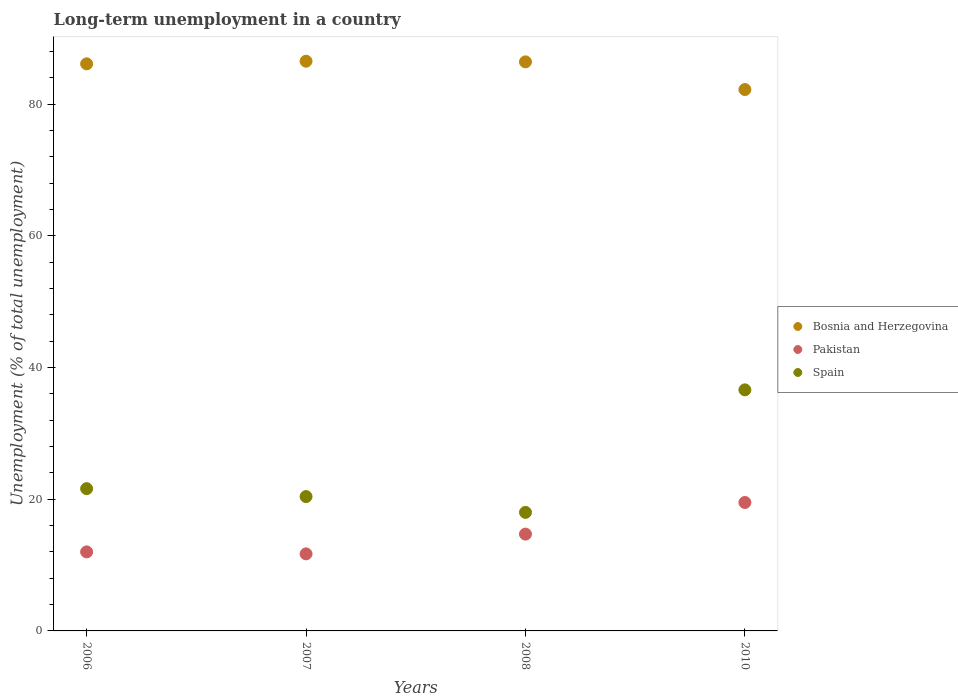Across all years, what is the minimum percentage of long-term unemployed population in Pakistan?
Provide a short and direct response. 11.7. In which year was the percentage of long-term unemployed population in Pakistan maximum?
Keep it short and to the point. 2010. What is the total percentage of long-term unemployed population in Spain in the graph?
Your response must be concise. 96.6. What is the difference between the percentage of long-term unemployed population in Bosnia and Herzegovina in 2006 and that in 2010?
Your answer should be compact. 3.9. What is the average percentage of long-term unemployed population in Pakistan per year?
Ensure brevity in your answer.  14.47. In the year 2006, what is the difference between the percentage of long-term unemployed population in Spain and percentage of long-term unemployed population in Pakistan?
Give a very brief answer. 9.6. In how many years, is the percentage of long-term unemployed population in Spain greater than 16 %?
Provide a succinct answer. 4. What is the ratio of the percentage of long-term unemployed population in Pakistan in 2007 to that in 2008?
Offer a terse response. 0.8. Is the difference between the percentage of long-term unemployed population in Spain in 2007 and 2010 greater than the difference between the percentage of long-term unemployed population in Pakistan in 2007 and 2010?
Offer a very short reply. No. What is the difference between the highest and the second highest percentage of long-term unemployed population in Spain?
Provide a short and direct response. 15. What is the difference between the highest and the lowest percentage of long-term unemployed population in Bosnia and Herzegovina?
Keep it short and to the point. 4.3. In how many years, is the percentage of long-term unemployed population in Spain greater than the average percentage of long-term unemployed population in Spain taken over all years?
Offer a very short reply. 1. Is the sum of the percentage of long-term unemployed population in Spain in 2006 and 2007 greater than the maximum percentage of long-term unemployed population in Pakistan across all years?
Give a very brief answer. Yes. Does the percentage of long-term unemployed population in Pakistan monotonically increase over the years?
Make the answer very short. No. Is the percentage of long-term unemployed population in Spain strictly greater than the percentage of long-term unemployed population in Pakistan over the years?
Keep it short and to the point. Yes. Is the percentage of long-term unemployed population in Pakistan strictly less than the percentage of long-term unemployed population in Spain over the years?
Keep it short and to the point. Yes. How many years are there in the graph?
Make the answer very short. 4. What is the difference between two consecutive major ticks on the Y-axis?
Provide a short and direct response. 20. Does the graph contain any zero values?
Keep it short and to the point. No. Does the graph contain grids?
Your response must be concise. No. Where does the legend appear in the graph?
Provide a short and direct response. Center right. What is the title of the graph?
Offer a terse response. Long-term unemployment in a country. Does "Colombia" appear as one of the legend labels in the graph?
Your answer should be very brief. No. What is the label or title of the X-axis?
Your response must be concise. Years. What is the label or title of the Y-axis?
Your answer should be very brief. Unemployment (% of total unemployment). What is the Unemployment (% of total unemployment) in Bosnia and Herzegovina in 2006?
Your answer should be compact. 86.1. What is the Unemployment (% of total unemployment) in Spain in 2006?
Offer a terse response. 21.6. What is the Unemployment (% of total unemployment) in Bosnia and Herzegovina in 2007?
Provide a succinct answer. 86.5. What is the Unemployment (% of total unemployment) in Pakistan in 2007?
Keep it short and to the point. 11.7. What is the Unemployment (% of total unemployment) in Spain in 2007?
Offer a terse response. 20.4. What is the Unemployment (% of total unemployment) of Bosnia and Herzegovina in 2008?
Offer a terse response. 86.4. What is the Unemployment (% of total unemployment) in Pakistan in 2008?
Your answer should be compact. 14.7. What is the Unemployment (% of total unemployment) in Bosnia and Herzegovina in 2010?
Make the answer very short. 82.2. What is the Unemployment (% of total unemployment) of Spain in 2010?
Provide a short and direct response. 36.6. Across all years, what is the maximum Unemployment (% of total unemployment) of Bosnia and Herzegovina?
Ensure brevity in your answer.  86.5. Across all years, what is the maximum Unemployment (% of total unemployment) of Pakistan?
Your answer should be compact. 19.5. Across all years, what is the maximum Unemployment (% of total unemployment) in Spain?
Offer a terse response. 36.6. Across all years, what is the minimum Unemployment (% of total unemployment) in Bosnia and Herzegovina?
Give a very brief answer. 82.2. Across all years, what is the minimum Unemployment (% of total unemployment) in Pakistan?
Your response must be concise. 11.7. Across all years, what is the minimum Unemployment (% of total unemployment) of Spain?
Offer a very short reply. 18. What is the total Unemployment (% of total unemployment) in Bosnia and Herzegovina in the graph?
Make the answer very short. 341.2. What is the total Unemployment (% of total unemployment) in Pakistan in the graph?
Make the answer very short. 57.9. What is the total Unemployment (% of total unemployment) in Spain in the graph?
Ensure brevity in your answer.  96.6. What is the difference between the Unemployment (% of total unemployment) in Pakistan in 2006 and that in 2007?
Give a very brief answer. 0.3. What is the difference between the Unemployment (% of total unemployment) in Spain in 2006 and that in 2007?
Give a very brief answer. 1.2. What is the difference between the Unemployment (% of total unemployment) in Bosnia and Herzegovina in 2006 and that in 2008?
Keep it short and to the point. -0.3. What is the difference between the Unemployment (% of total unemployment) of Spain in 2006 and that in 2008?
Offer a terse response. 3.6. What is the difference between the Unemployment (% of total unemployment) of Bosnia and Herzegovina in 2006 and that in 2010?
Provide a succinct answer. 3.9. What is the difference between the Unemployment (% of total unemployment) of Pakistan in 2006 and that in 2010?
Offer a terse response. -7.5. What is the difference between the Unemployment (% of total unemployment) of Pakistan in 2007 and that in 2010?
Offer a very short reply. -7.8. What is the difference between the Unemployment (% of total unemployment) of Spain in 2007 and that in 2010?
Provide a succinct answer. -16.2. What is the difference between the Unemployment (% of total unemployment) in Pakistan in 2008 and that in 2010?
Your answer should be very brief. -4.8. What is the difference between the Unemployment (% of total unemployment) in Spain in 2008 and that in 2010?
Keep it short and to the point. -18.6. What is the difference between the Unemployment (% of total unemployment) of Bosnia and Herzegovina in 2006 and the Unemployment (% of total unemployment) of Pakistan in 2007?
Ensure brevity in your answer.  74.4. What is the difference between the Unemployment (% of total unemployment) of Bosnia and Herzegovina in 2006 and the Unemployment (% of total unemployment) of Spain in 2007?
Offer a terse response. 65.7. What is the difference between the Unemployment (% of total unemployment) in Pakistan in 2006 and the Unemployment (% of total unemployment) in Spain in 2007?
Offer a terse response. -8.4. What is the difference between the Unemployment (% of total unemployment) of Bosnia and Herzegovina in 2006 and the Unemployment (% of total unemployment) of Pakistan in 2008?
Your answer should be compact. 71.4. What is the difference between the Unemployment (% of total unemployment) of Bosnia and Herzegovina in 2006 and the Unemployment (% of total unemployment) of Spain in 2008?
Provide a short and direct response. 68.1. What is the difference between the Unemployment (% of total unemployment) in Pakistan in 2006 and the Unemployment (% of total unemployment) in Spain in 2008?
Your answer should be very brief. -6. What is the difference between the Unemployment (% of total unemployment) of Bosnia and Herzegovina in 2006 and the Unemployment (% of total unemployment) of Pakistan in 2010?
Offer a terse response. 66.6. What is the difference between the Unemployment (% of total unemployment) of Bosnia and Herzegovina in 2006 and the Unemployment (% of total unemployment) of Spain in 2010?
Provide a succinct answer. 49.5. What is the difference between the Unemployment (% of total unemployment) of Pakistan in 2006 and the Unemployment (% of total unemployment) of Spain in 2010?
Your response must be concise. -24.6. What is the difference between the Unemployment (% of total unemployment) of Bosnia and Herzegovina in 2007 and the Unemployment (% of total unemployment) of Pakistan in 2008?
Make the answer very short. 71.8. What is the difference between the Unemployment (% of total unemployment) in Bosnia and Herzegovina in 2007 and the Unemployment (% of total unemployment) in Spain in 2008?
Give a very brief answer. 68.5. What is the difference between the Unemployment (% of total unemployment) in Bosnia and Herzegovina in 2007 and the Unemployment (% of total unemployment) in Pakistan in 2010?
Your answer should be very brief. 67. What is the difference between the Unemployment (% of total unemployment) in Bosnia and Herzegovina in 2007 and the Unemployment (% of total unemployment) in Spain in 2010?
Your response must be concise. 49.9. What is the difference between the Unemployment (% of total unemployment) in Pakistan in 2007 and the Unemployment (% of total unemployment) in Spain in 2010?
Ensure brevity in your answer.  -24.9. What is the difference between the Unemployment (% of total unemployment) in Bosnia and Herzegovina in 2008 and the Unemployment (% of total unemployment) in Pakistan in 2010?
Provide a succinct answer. 66.9. What is the difference between the Unemployment (% of total unemployment) in Bosnia and Herzegovina in 2008 and the Unemployment (% of total unemployment) in Spain in 2010?
Your answer should be very brief. 49.8. What is the difference between the Unemployment (% of total unemployment) of Pakistan in 2008 and the Unemployment (% of total unemployment) of Spain in 2010?
Ensure brevity in your answer.  -21.9. What is the average Unemployment (% of total unemployment) of Bosnia and Herzegovina per year?
Keep it short and to the point. 85.3. What is the average Unemployment (% of total unemployment) of Pakistan per year?
Your answer should be very brief. 14.47. What is the average Unemployment (% of total unemployment) in Spain per year?
Your response must be concise. 24.15. In the year 2006, what is the difference between the Unemployment (% of total unemployment) of Bosnia and Herzegovina and Unemployment (% of total unemployment) of Pakistan?
Offer a terse response. 74.1. In the year 2006, what is the difference between the Unemployment (% of total unemployment) in Bosnia and Herzegovina and Unemployment (% of total unemployment) in Spain?
Offer a very short reply. 64.5. In the year 2006, what is the difference between the Unemployment (% of total unemployment) of Pakistan and Unemployment (% of total unemployment) of Spain?
Your answer should be very brief. -9.6. In the year 2007, what is the difference between the Unemployment (% of total unemployment) of Bosnia and Herzegovina and Unemployment (% of total unemployment) of Pakistan?
Ensure brevity in your answer.  74.8. In the year 2007, what is the difference between the Unemployment (% of total unemployment) in Bosnia and Herzegovina and Unemployment (% of total unemployment) in Spain?
Ensure brevity in your answer.  66.1. In the year 2007, what is the difference between the Unemployment (% of total unemployment) in Pakistan and Unemployment (% of total unemployment) in Spain?
Provide a short and direct response. -8.7. In the year 2008, what is the difference between the Unemployment (% of total unemployment) in Bosnia and Herzegovina and Unemployment (% of total unemployment) in Pakistan?
Make the answer very short. 71.7. In the year 2008, what is the difference between the Unemployment (% of total unemployment) of Bosnia and Herzegovina and Unemployment (% of total unemployment) of Spain?
Your response must be concise. 68.4. In the year 2010, what is the difference between the Unemployment (% of total unemployment) in Bosnia and Herzegovina and Unemployment (% of total unemployment) in Pakistan?
Ensure brevity in your answer.  62.7. In the year 2010, what is the difference between the Unemployment (% of total unemployment) of Bosnia and Herzegovina and Unemployment (% of total unemployment) of Spain?
Give a very brief answer. 45.6. In the year 2010, what is the difference between the Unemployment (% of total unemployment) in Pakistan and Unemployment (% of total unemployment) in Spain?
Your answer should be compact. -17.1. What is the ratio of the Unemployment (% of total unemployment) in Bosnia and Herzegovina in 2006 to that in 2007?
Offer a very short reply. 1. What is the ratio of the Unemployment (% of total unemployment) of Pakistan in 2006 to that in 2007?
Offer a very short reply. 1.03. What is the ratio of the Unemployment (% of total unemployment) of Spain in 2006 to that in 2007?
Provide a short and direct response. 1.06. What is the ratio of the Unemployment (% of total unemployment) in Bosnia and Herzegovina in 2006 to that in 2008?
Your answer should be compact. 1. What is the ratio of the Unemployment (% of total unemployment) in Pakistan in 2006 to that in 2008?
Your response must be concise. 0.82. What is the ratio of the Unemployment (% of total unemployment) in Spain in 2006 to that in 2008?
Your answer should be compact. 1.2. What is the ratio of the Unemployment (% of total unemployment) in Bosnia and Herzegovina in 2006 to that in 2010?
Give a very brief answer. 1.05. What is the ratio of the Unemployment (% of total unemployment) in Pakistan in 2006 to that in 2010?
Provide a short and direct response. 0.62. What is the ratio of the Unemployment (% of total unemployment) in Spain in 2006 to that in 2010?
Keep it short and to the point. 0.59. What is the ratio of the Unemployment (% of total unemployment) of Pakistan in 2007 to that in 2008?
Keep it short and to the point. 0.8. What is the ratio of the Unemployment (% of total unemployment) of Spain in 2007 to that in 2008?
Ensure brevity in your answer.  1.13. What is the ratio of the Unemployment (% of total unemployment) in Bosnia and Herzegovina in 2007 to that in 2010?
Offer a very short reply. 1.05. What is the ratio of the Unemployment (% of total unemployment) in Pakistan in 2007 to that in 2010?
Ensure brevity in your answer.  0.6. What is the ratio of the Unemployment (% of total unemployment) of Spain in 2007 to that in 2010?
Your response must be concise. 0.56. What is the ratio of the Unemployment (% of total unemployment) of Bosnia and Herzegovina in 2008 to that in 2010?
Offer a very short reply. 1.05. What is the ratio of the Unemployment (% of total unemployment) in Pakistan in 2008 to that in 2010?
Keep it short and to the point. 0.75. What is the ratio of the Unemployment (% of total unemployment) in Spain in 2008 to that in 2010?
Provide a succinct answer. 0.49. What is the difference between the highest and the second highest Unemployment (% of total unemployment) of Bosnia and Herzegovina?
Ensure brevity in your answer.  0.1. What is the difference between the highest and the second highest Unemployment (% of total unemployment) in Spain?
Ensure brevity in your answer.  15. What is the difference between the highest and the lowest Unemployment (% of total unemployment) of Bosnia and Herzegovina?
Keep it short and to the point. 4.3. What is the difference between the highest and the lowest Unemployment (% of total unemployment) in Pakistan?
Your response must be concise. 7.8. 